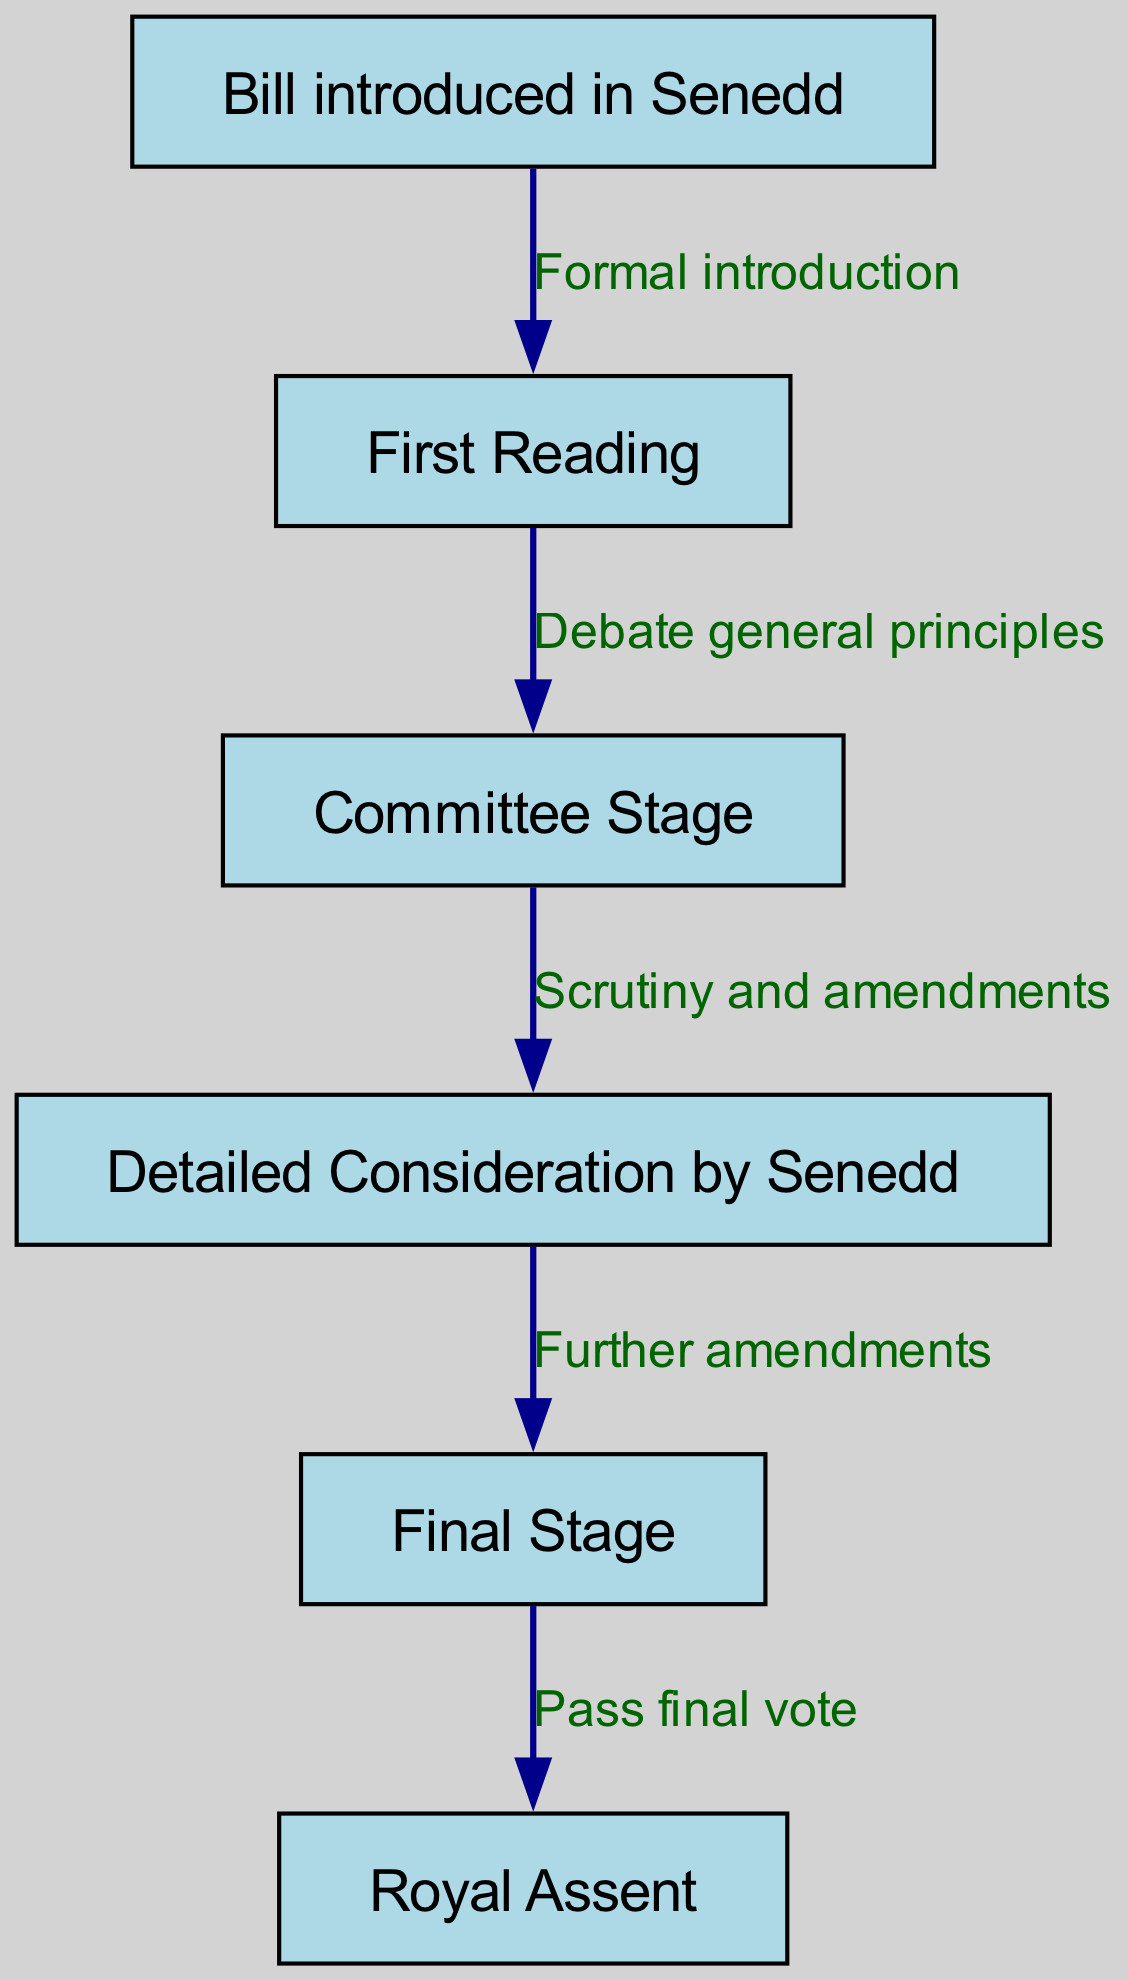What is the first step in the legislative process? The diagram starts with the first node, which is "Bill introduced in Senedd," indicating that this is the initial step in the process.
Answer: Bill introduced in Senedd How many nodes are in the diagram? There are six nodes listed in the provided data, representing different stages in the legislative process.
Answer: 6 What is the edge label between the "First Reading" and "Committee Stage"? The edge connecting these two nodes is labeled "Debate general principles," as indicated in the edges section of the data.
Answer: Debate general principles What occurs after the "Committee Stage"? The diagram shows that after the "Committee Stage," the process proceeds to "Detailed Consideration by Senedd," indicating the next step.
Answer: Detailed Consideration by Senedd What is the final step in the legislative process? The last node in the diagram is "Royal Assent," which is the conclusive action that ends the legislative process after a bill has passed all previous stages.
Answer: Royal Assent What are the main actions taken during the "Detailed Consideration by Senedd"? The edge leading from "Detailed Consideration by Senedd" to "Final Stage" is labeled "Further amendments," which indicates the primary action that occurs at this stage.
Answer: Further amendments What two stages are directly related by a transition that includes amendments? The transition between "Committee Stage" and "Detailed Consideration by Senedd" includes scrutiny and amendments, thus these two stages are connected by the action of considering amendments.
Answer: Scrutiny and amendments What needs to happen before a bill receives Royal Assent? Before a bill can receive Royal Assent, it must pass a final vote, as shown by the transition from "Final Stage" to "Royal Assent" in the diagram.
Answer: Pass final vote 